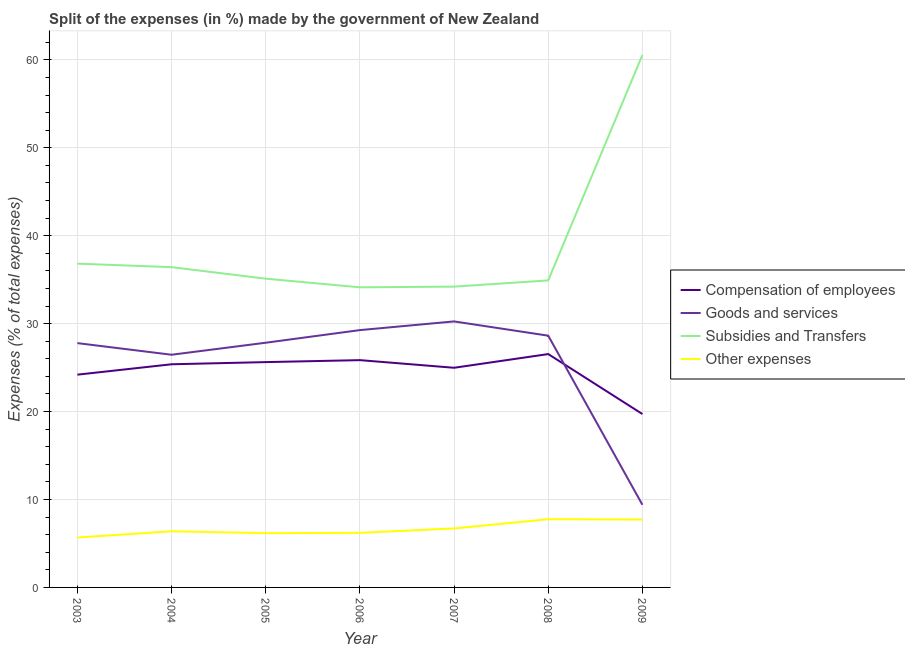How many different coloured lines are there?
Make the answer very short. 4. Does the line corresponding to percentage of amount spent on other expenses intersect with the line corresponding to percentage of amount spent on subsidies?
Ensure brevity in your answer.  No. Is the number of lines equal to the number of legend labels?
Ensure brevity in your answer.  Yes. What is the percentage of amount spent on other expenses in 2003?
Ensure brevity in your answer.  5.67. Across all years, what is the maximum percentage of amount spent on other expenses?
Provide a succinct answer. 7.75. Across all years, what is the minimum percentage of amount spent on other expenses?
Provide a short and direct response. 5.67. In which year was the percentage of amount spent on compensation of employees minimum?
Offer a terse response. 2009. What is the total percentage of amount spent on goods and services in the graph?
Give a very brief answer. 179.62. What is the difference between the percentage of amount spent on other expenses in 2007 and that in 2008?
Ensure brevity in your answer.  -1.05. What is the difference between the percentage of amount spent on other expenses in 2006 and the percentage of amount spent on compensation of employees in 2008?
Provide a succinct answer. -20.33. What is the average percentage of amount spent on goods and services per year?
Give a very brief answer. 25.66. In the year 2009, what is the difference between the percentage of amount spent on other expenses and percentage of amount spent on subsidies?
Keep it short and to the point. -52.83. In how many years, is the percentage of amount spent on goods and services greater than 16 %?
Provide a succinct answer. 6. What is the ratio of the percentage of amount spent on compensation of employees in 2003 to that in 2004?
Your answer should be compact. 0.95. Is the percentage of amount spent on compensation of employees in 2005 less than that in 2009?
Ensure brevity in your answer.  No. What is the difference between the highest and the second highest percentage of amount spent on goods and services?
Offer a terse response. 0.99. What is the difference between the highest and the lowest percentage of amount spent on subsidies?
Ensure brevity in your answer.  26.43. In how many years, is the percentage of amount spent on goods and services greater than the average percentage of amount spent on goods and services taken over all years?
Your answer should be very brief. 6. Is the sum of the percentage of amount spent on goods and services in 2003 and 2009 greater than the maximum percentage of amount spent on other expenses across all years?
Offer a terse response. Yes. Is it the case that in every year, the sum of the percentage of amount spent on subsidies and percentage of amount spent on goods and services is greater than the sum of percentage of amount spent on compensation of employees and percentage of amount spent on other expenses?
Your answer should be very brief. Yes. How many years are there in the graph?
Provide a succinct answer. 7. What is the difference between two consecutive major ticks on the Y-axis?
Offer a terse response. 10. Does the graph contain any zero values?
Ensure brevity in your answer.  No. Does the graph contain grids?
Offer a very short reply. Yes. Where does the legend appear in the graph?
Your response must be concise. Center right. What is the title of the graph?
Offer a terse response. Split of the expenses (in %) made by the government of New Zealand. Does "WFP" appear as one of the legend labels in the graph?
Your answer should be compact. No. What is the label or title of the X-axis?
Keep it short and to the point. Year. What is the label or title of the Y-axis?
Your answer should be compact. Expenses (% of total expenses). What is the Expenses (% of total expenses) of Compensation of employees in 2003?
Offer a very short reply. 24.2. What is the Expenses (% of total expenses) in Goods and services in 2003?
Your answer should be compact. 27.78. What is the Expenses (% of total expenses) of Subsidies and Transfers in 2003?
Your answer should be compact. 36.82. What is the Expenses (% of total expenses) in Other expenses in 2003?
Make the answer very short. 5.67. What is the Expenses (% of total expenses) of Compensation of employees in 2004?
Provide a succinct answer. 25.38. What is the Expenses (% of total expenses) of Goods and services in 2004?
Your answer should be compact. 26.46. What is the Expenses (% of total expenses) in Subsidies and Transfers in 2004?
Keep it short and to the point. 36.42. What is the Expenses (% of total expenses) in Other expenses in 2004?
Your response must be concise. 6.38. What is the Expenses (% of total expenses) of Compensation of employees in 2005?
Offer a terse response. 25.62. What is the Expenses (% of total expenses) of Goods and services in 2005?
Your response must be concise. 27.83. What is the Expenses (% of total expenses) in Subsidies and Transfers in 2005?
Your answer should be very brief. 35.11. What is the Expenses (% of total expenses) of Other expenses in 2005?
Provide a short and direct response. 6.17. What is the Expenses (% of total expenses) in Compensation of employees in 2006?
Your response must be concise. 25.85. What is the Expenses (% of total expenses) in Goods and services in 2006?
Make the answer very short. 29.26. What is the Expenses (% of total expenses) in Subsidies and Transfers in 2006?
Provide a short and direct response. 34.13. What is the Expenses (% of total expenses) in Other expenses in 2006?
Provide a short and direct response. 6.21. What is the Expenses (% of total expenses) in Compensation of employees in 2007?
Offer a very short reply. 24.98. What is the Expenses (% of total expenses) in Goods and services in 2007?
Your response must be concise. 30.25. What is the Expenses (% of total expenses) in Subsidies and Transfers in 2007?
Provide a short and direct response. 34.21. What is the Expenses (% of total expenses) in Other expenses in 2007?
Provide a succinct answer. 6.71. What is the Expenses (% of total expenses) of Compensation of employees in 2008?
Offer a terse response. 26.54. What is the Expenses (% of total expenses) of Goods and services in 2008?
Your response must be concise. 28.63. What is the Expenses (% of total expenses) in Subsidies and Transfers in 2008?
Offer a terse response. 34.91. What is the Expenses (% of total expenses) in Other expenses in 2008?
Keep it short and to the point. 7.75. What is the Expenses (% of total expenses) of Compensation of employees in 2009?
Give a very brief answer. 19.72. What is the Expenses (% of total expenses) of Goods and services in 2009?
Provide a succinct answer. 9.4. What is the Expenses (% of total expenses) of Subsidies and Transfers in 2009?
Your answer should be very brief. 60.55. What is the Expenses (% of total expenses) of Other expenses in 2009?
Keep it short and to the point. 7.73. Across all years, what is the maximum Expenses (% of total expenses) in Compensation of employees?
Keep it short and to the point. 26.54. Across all years, what is the maximum Expenses (% of total expenses) of Goods and services?
Your answer should be compact. 30.25. Across all years, what is the maximum Expenses (% of total expenses) in Subsidies and Transfers?
Make the answer very short. 60.55. Across all years, what is the maximum Expenses (% of total expenses) in Other expenses?
Offer a terse response. 7.75. Across all years, what is the minimum Expenses (% of total expenses) in Compensation of employees?
Offer a very short reply. 19.72. Across all years, what is the minimum Expenses (% of total expenses) in Goods and services?
Your answer should be very brief. 9.4. Across all years, what is the minimum Expenses (% of total expenses) in Subsidies and Transfers?
Your response must be concise. 34.13. Across all years, what is the minimum Expenses (% of total expenses) in Other expenses?
Offer a terse response. 5.67. What is the total Expenses (% of total expenses) of Compensation of employees in the graph?
Give a very brief answer. 172.28. What is the total Expenses (% of total expenses) of Goods and services in the graph?
Offer a very short reply. 179.62. What is the total Expenses (% of total expenses) of Subsidies and Transfers in the graph?
Give a very brief answer. 272.16. What is the total Expenses (% of total expenses) in Other expenses in the graph?
Provide a succinct answer. 46.62. What is the difference between the Expenses (% of total expenses) in Compensation of employees in 2003 and that in 2004?
Ensure brevity in your answer.  -1.18. What is the difference between the Expenses (% of total expenses) of Goods and services in 2003 and that in 2004?
Offer a terse response. 1.32. What is the difference between the Expenses (% of total expenses) of Subsidies and Transfers in 2003 and that in 2004?
Give a very brief answer. 0.4. What is the difference between the Expenses (% of total expenses) of Other expenses in 2003 and that in 2004?
Your answer should be very brief. -0.71. What is the difference between the Expenses (% of total expenses) of Compensation of employees in 2003 and that in 2005?
Make the answer very short. -1.43. What is the difference between the Expenses (% of total expenses) of Goods and services in 2003 and that in 2005?
Your answer should be very brief. -0.05. What is the difference between the Expenses (% of total expenses) of Subsidies and Transfers in 2003 and that in 2005?
Your response must be concise. 1.71. What is the difference between the Expenses (% of total expenses) of Other expenses in 2003 and that in 2005?
Offer a very short reply. -0.5. What is the difference between the Expenses (% of total expenses) of Compensation of employees in 2003 and that in 2006?
Your response must be concise. -1.65. What is the difference between the Expenses (% of total expenses) in Goods and services in 2003 and that in 2006?
Offer a very short reply. -1.48. What is the difference between the Expenses (% of total expenses) in Subsidies and Transfers in 2003 and that in 2006?
Ensure brevity in your answer.  2.69. What is the difference between the Expenses (% of total expenses) in Other expenses in 2003 and that in 2006?
Your response must be concise. -0.54. What is the difference between the Expenses (% of total expenses) in Compensation of employees in 2003 and that in 2007?
Ensure brevity in your answer.  -0.78. What is the difference between the Expenses (% of total expenses) of Goods and services in 2003 and that in 2007?
Make the answer very short. -2.47. What is the difference between the Expenses (% of total expenses) of Subsidies and Transfers in 2003 and that in 2007?
Ensure brevity in your answer.  2.62. What is the difference between the Expenses (% of total expenses) of Other expenses in 2003 and that in 2007?
Keep it short and to the point. -1.04. What is the difference between the Expenses (% of total expenses) of Compensation of employees in 2003 and that in 2008?
Your response must be concise. -2.34. What is the difference between the Expenses (% of total expenses) in Goods and services in 2003 and that in 2008?
Ensure brevity in your answer.  -0.85. What is the difference between the Expenses (% of total expenses) of Subsidies and Transfers in 2003 and that in 2008?
Offer a very short reply. 1.91. What is the difference between the Expenses (% of total expenses) in Other expenses in 2003 and that in 2008?
Ensure brevity in your answer.  -2.08. What is the difference between the Expenses (% of total expenses) in Compensation of employees in 2003 and that in 2009?
Keep it short and to the point. 4.48. What is the difference between the Expenses (% of total expenses) in Goods and services in 2003 and that in 2009?
Offer a terse response. 18.38. What is the difference between the Expenses (% of total expenses) in Subsidies and Transfers in 2003 and that in 2009?
Ensure brevity in your answer.  -23.73. What is the difference between the Expenses (% of total expenses) of Other expenses in 2003 and that in 2009?
Your response must be concise. -2.06. What is the difference between the Expenses (% of total expenses) of Compensation of employees in 2004 and that in 2005?
Make the answer very short. -0.25. What is the difference between the Expenses (% of total expenses) in Goods and services in 2004 and that in 2005?
Offer a terse response. -1.37. What is the difference between the Expenses (% of total expenses) in Subsidies and Transfers in 2004 and that in 2005?
Provide a short and direct response. 1.31. What is the difference between the Expenses (% of total expenses) of Other expenses in 2004 and that in 2005?
Give a very brief answer. 0.21. What is the difference between the Expenses (% of total expenses) in Compensation of employees in 2004 and that in 2006?
Your answer should be compact. -0.47. What is the difference between the Expenses (% of total expenses) in Goods and services in 2004 and that in 2006?
Your answer should be very brief. -2.8. What is the difference between the Expenses (% of total expenses) in Subsidies and Transfers in 2004 and that in 2006?
Give a very brief answer. 2.29. What is the difference between the Expenses (% of total expenses) in Other expenses in 2004 and that in 2006?
Offer a terse response. 0.17. What is the difference between the Expenses (% of total expenses) in Compensation of employees in 2004 and that in 2007?
Give a very brief answer. 0.4. What is the difference between the Expenses (% of total expenses) in Goods and services in 2004 and that in 2007?
Ensure brevity in your answer.  -3.79. What is the difference between the Expenses (% of total expenses) in Subsidies and Transfers in 2004 and that in 2007?
Offer a terse response. 2.22. What is the difference between the Expenses (% of total expenses) of Other expenses in 2004 and that in 2007?
Provide a succinct answer. -0.32. What is the difference between the Expenses (% of total expenses) in Compensation of employees in 2004 and that in 2008?
Offer a terse response. -1.16. What is the difference between the Expenses (% of total expenses) in Goods and services in 2004 and that in 2008?
Provide a succinct answer. -2.17. What is the difference between the Expenses (% of total expenses) of Subsidies and Transfers in 2004 and that in 2008?
Ensure brevity in your answer.  1.51. What is the difference between the Expenses (% of total expenses) of Other expenses in 2004 and that in 2008?
Give a very brief answer. -1.37. What is the difference between the Expenses (% of total expenses) of Compensation of employees in 2004 and that in 2009?
Offer a very short reply. 5.66. What is the difference between the Expenses (% of total expenses) of Goods and services in 2004 and that in 2009?
Provide a succinct answer. 17.06. What is the difference between the Expenses (% of total expenses) of Subsidies and Transfers in 2004 and that in 2009?
Offer a terse response. -24.13. What is the difference between the Expenses (% of total expenses) in Other expenses in 2004 and that in 2009?
Provide a succinct answer. -1.34. What is the difference between the Expenses (% of total expenses) in Compensation of employees in 2005 and that in 2006?
Give a very brief answer. -0.22. What is the difference between the Expenses (% of total expenses) in Goods and services in 2005 and that in 2006?
Your answer should be compact. -1.44. What is the difference between the Expenses (% of total expenses) in Subsidies and Transfers in 2005 and that in 2006?
Offer a terse response. 0.98. What is the difference between the Expenses (% of total expenses) in Other expenses in 2005 and that in 2006?
Ensure brevity in your answer.  -0.04. What is the difference between the Expenses (% of total expenses) of Compensation of employees in 2005 and that in 2007?
Offer a terse response. 0.64. What is the difference between the Expenses (% of total expenses) of Goods and services in 2005 and that in 2007?
Provide a short and direct response. -2.42. What is the difference between the Expenses (% of total expenses) in Subsidies and Transfers in 2005 and that in 2007?
Give a very brief answer. 0.91. What is the difference between the Expenses (% of total expenses) of Other expenses in 2005 and that in 2007?
Give a very brief answer. -0.54. What is the difference between the Expenses (% of total expenses) in Compensation of employees in 2005 and that in 2008?
Give a very brief answer. -0.91. What is the difference between the Expenses (% of total expenses) in Goods and services in 2005 and that in 2008?
Keep it short and to the point. -0.8. What is the difference between the Expenses (% of total expenses) of Subsidies and Transfers in 2005 and that in 2008?
Give a very brief answer. 0.2. What is the difference between the Expenses (% of total expenses) in Other expenses in 2005 and that in 2008?
Keep it short and to the point. -1.58. What is the difference between the Expenses (% of total expenses) of Compensation of employees in 2005 and that in 2009?
Make the answer very short. 5.9. What is the difference between the Expenses (% of total expenses) in Goods and services in 2005 and that in 2009?
Offer a terse response. 18.43. What is the difference between the Expenses (% of total expenses) in Subsidies and Transfers in 2005 and that in 2009?
Your answer should be very brief. -25.44. What is the difference between the Expenses (% of total expenses) of Other expenses in 2005 and that in 2009?
Your response must be concise. -1.56. What is the difference between the Expenses (% of total expenses) in Compensation of employees in 2006 and that in 2007?
Make the answer very short. 0.87. What is the difference between the Expenses (% of total expenses) in Goods and services in 2006 and that in 2007?
Your answer should be very brief. -0.99. What is the difference between the Expenses (% of total expenses) in Subsidies and Transfers in 2006 and that in 2007?
Offer a very short reply. -0.08. What is the difference between the Expenses (% of total expenses) of Other expenses in 2006 and that in 2007?
Your response must be concise. -0.5. What is the difference between the Expenses (% of total expenses) of Compensation of employees in 2006 and that in 2008?
Offer a terse response. -0.69. What is the difference between the Expenses (% of total expenses) in Goods and services in 2006 and that in 2008?
Give a very brief answer. 0.63. What is the difference between the Expenses (% of total expenses) of Subsidies and Transfers in 2006 and that in 2008?
Make the answer very short. -0.79. What is the difference between the Expenses (% of total expenses) in Other expenses in 2006 and that in 2008?
Offer a terse response. -1.55. What is the difference between the Expenses (% of total expenses) of Compensation of employees in 2006 and that in 2009?
Your response must be concise. 6.13. What is the difference between the Expenses (% of total expenses) of Goods and services in 2006 and that in 2009?
Your response must be concise. 19.87. What is the difference between the Expenses (% of total expenses) of Subsidies and Transfers in 2006 and that in 2009?
Your answer should be compact. -26.43. What is the difference between the Expenses (% of total expenses) in Other expenses in 2006 and that in 2009?
Offer a terse response. -1.52. What is the difference between the Expenses (% of total expenses) of Compensation of employees in 2007 and that in 2008?
Your response must be concise. -1.56. What is the difference between the Expenses (% of total expenses) in Goods and services in 2007 and that in 2008?
Your answer should be compact. 1.62. What is the difference between the Expenses (% of total expenses) in Subsidies and Transfers in 2007 and that in 2008?
Make the answer very short. -0.71. What is the difference between the Expenses (% of total expenses) of Other expenses in 2007 and that in 2008?
Your answer should be very brief. -1.05. What is the difference between the Expenses (% of total expenses) of Compensation of employees in 2007 and that in 2009?
Give a very brief answer. 5.26. What is the difference between the Expenses (% of total expenses) of Goods and services in 2007 and that in 2009?
Your answer should be compact. 20.85. What is the difference between the Expenses (% of total expenses) of Subsidies and Transfers in 2007 and that in 2009?
Give a very brief answer. -26.35. What is the difference between the Expenses (% of total expenses) in Other expenses in 2007 and that in 2009?
Offer a very short reply. -1.02. What is the difference between the Expenses (% of total expenses) in Compensation of employees in 2008 and that in 2009?
Your response must be concise. 6.82. What is the difference between the Expenses (% of total expenses) in Goods and services in 2008 and that in 2009?
Your response must be concise. 19.23. What is the difference between the Expenses (% of total expenses) in Subsidies and Transfers in 2008 and that in 2009?
Provide a succinct answer. -25.64. What is the difference between the Expenses (% of total expenses) in Other expenses in 2008 and that in 2009?
Provide a short and direct response. 0.03. What is the difference between the Expenses (% of total expenses) in Compensation of employees in 2003 and the Expenses (% of total expenses) in Goods and services in 2004?
Make the answer very short. -2.26. What is the difference between the Expenses (% of total expenses) in Compensation of employees in 2003 and the Expenses (% of total expenses) in Subsidies and Transfers in 2004?
Ensure brevity in your answer.  -12.23. What is the difference between the Expenses (% of total expenses) in Compensation of employees in 2003 and the Expenses (% of total expenses) in Other expenses in 2004?
Keep it short and to the point. 17.81. What is the difference between the Expenses (% of total expenses) of Goods and services in 2003 and the Expenses (% of total expenses) of Subsidies and Transfers in 2004?
Give a very brief answer. -8.64. What is the difference between the Expenses (% of total expenses) of Goods and services in 2003 and the Expenses (% of total expenses) of Other expenses in 2004?
Offer a very short reply. 21.4. What is the difference between the Expenses (% of total expenses) of Subsidies and Transfers in 2003 and the Expenses (% of total expenses) of Other expenses in 2004?
Make the answer very short. 30.44. What is the difference between the Expenses (% of total expenses) of Compensation of employees in 2003 and the Expenses (% of total expenses) of Goods and services in 2005?
Keep it short and to the point. -3.63. What is the difference between the Expenses (% of total expenses) in Compensation of employees in 2003 and the Expenses (% of total expenses) in Subsidies and Transfers in 2005?
Your answer should be compact. -10.92. What is the difference between the Expenses (% of total expenses) in Compensation of employees in 2003 and the Expenses (% of total expenses) in Other expenses in 2005?
Your response must be concise. 18.03. What is the difference between the Expenses (% of total expenses) of Goods and services in 2003 and the Expenses (% of total expenses) of Subsidies and Transfers in 2005?
Your answer should be compact. -7.33. What is the difference between the Expenses (% of total expenses) in Goods and services in 2003 and the Expenses (% of total expenses) in Other expenses in 2005?
Offer a terse response. 21.61. What is the difference between the Expenses (% of total expenses) in Subsidies and Transfers in 2003 and the Expenses (% of total expenses) in Other expenses in 2005?
Ensure brevity in your answer.  30.65. What is the difference between the Expenses (% of total expenses) of Compensation of employees in 2003 and the Expenses (% of total expenses) of Goods and services in 2006?
Offer a terse response. -5.07. What is the difference between the Expenses (% of total expenses) of Compensation of employees in 2003 and the Expenses (% of total expenses) of Subsidies and Transfers in 2006?
Provide a succinct answer. -9.93. What is the difference between the Expenses (% of total expenses) of Compensation of employees in 2003 and the Expenses (% of total expenses) of Other expenses in 2006?
Make the answer very short. 17.99. What is the difference between the Expenses (% of total expenses) in Goods and services in 2003 and the Expenses (% of total expenses) in Subsidies and Transfers in 2006?
Offer a very short reply. -6.35. What is the difference between the Expenses (% of total expenses) in Goods and services in 2003 and the Expenses (% of total expenses) in Other expenses in 2006?
Ensure brevity in your answer.  21.57. What is the difference between the Expenses (% of total expenses) in Subsidies and Transfers in 2003 and the Expenses (% of total expenses) in Other expenses in 2006?
Your answer should be very brief. 30.61. What is the difference between the Expenses (% of total expenses) in Compensation of employees in 2003 and the Expenses (% of total expenses) in Goods and services in 2007?
Provide a short and direct response. -6.05. What is the difference between the Expenses (% of total expenses) of Compensation of employees in 2003 and the Expenses (% of total expenses) of Subsidies and Transfers in 2007?
Your answer should be compact. -10.01. What is the difference between the Expenses (% of total expenses) of Compensation of employees in 2003 and the Expenses (% of total expenses) of Other expenses in 2007?
Offer a very short reply. 17.49. What is the difference between the Expenses (% of total expenses) of Goods and services in 2003 and the Expenses (% of total expenses) of Subsidies and Transfers in 2007?
Provide a succinct answer. -6.42. What is the difference between the Expenses (% of total expenses) of Goods and services in 2003 and the Expenses (% of total expenses) of Other expenses in 2007?
Give a very brief answer. 21.08. What is the difference between the Expenses (% of total expenses) in Subsidies and Transfers in 2003 and the Expenses (% of total expenses) in Other expenses in 2007?
Give a very brief answer. 30.11. What is the difference between the Expenses (% of total expenses) of Compensation of employees in 2003 and the Expenses (% of total expenses) of Goods and services in 2008?
Provide a short and direct response. -4.43. What is the difference between the Expenses (% of total expenses) in Compensation of employees in 2003 and the Expenses (% of total expenses) in Subsidies and Transfers in 2008?
Provide a short and direct response. -10.72. What is the difference between the Expenses (% of total expenses) of Compensation of employees in 2003 and the Expenses (% of total expenses) of Other expenses in 2008?
Make the answer very short. 16.44. What is the difference between the Expenses (% of total expenses) in Goods and services in 2003 and the Expenses (% of total expenses) in Subsidies and Transfers in 2008?
Provide a short and direct response. -7.13. What is the difference between the Expenses (% of total expenses) in Goods and services in 2003 and the Expenses (% of total expenses) in Other expenses in 2008?
Your answer should be compact. 20.03. What is the difference between the Expenses (% of total expenses) in Subsidies and Transfers in 2003 and the Expenses (% of total expenses) in Other expenses in 2008?
Provide a succinct answer. 29.07. What is the difference between the Expenses (% of total expenses) in Compensation of employees in 2003 and the Expenses (% of total expenses) in Goods and services in 2009?
Provide a short and direct response. 14.8. What is the difference between the Expenses (% of total expenses) of Compensation of employees in 2003 and the Expenses (% of total expenses) of Subsidies and Transfers in 2009?
Offer a very short reply. -36.36. What is the difference between the Expenses (% of total expenses) of Compensation of employees in 2003 and the Expenses (% of total expenses) of Other expenses in 2009?
Your response must be concise. 16.47. What is the difference between the Expenses (% of total expenses) in Goods and services in 2003 and the Expenses (% of total expenses) in Subsidies and Transfers in 2009?
Your answer should be very brief. -32.77. What is the difference between the Expenses (% of total expenses) of Goods and services in 2003 and the Expenses (% of total expenses) of Other expenses in 2009?
Provide a short and direct response. 20.05. What is the difference between the Expenses (% of total expenses) of Subsidies and Transfers in 2003 and the Expenses (% of total expenses) of Other expenses in 2009?
Provide a short and direct response. 29.09. What is the difference between the Expenses (% of total expenses) of Compensation of employees in 2004 and the Expenses (% of total expenses) of Goods and services in 2005?
Your answer should be very brief. -2.45. What is the difference between the Expenses (% of total expenses) of Compensation of employees in 2004 and the Expenses (% of total expenses) of Subsidies and Transfers in 2005?
Your answer should be very brief. -9.73. What is the difference between the Expenses (% of total expenses) in Compensation of employees in 2004 and the Expenses (% of total expenses) in Other expenses in 2005?
Your response must be concise. 19.21. What is the difference between the Expenses (% of total expenses) of Goods and services in 2004 and the Expenses (% of total expenses) of Subsidies and Transfers in 2005?
Provide a succinct answer. -8.65. What is the difference between the Expenses (% of total expenses) in Goods and services in 2004 and the Expenses (% of total expenses) in Other expenses in 2005?
Offer a very short reply. 20.29. What is the difference between the Expenses (% of total expenses) in Subsidies and Transfers in 2004 and the Expenses (% of total expenses) in Other expenses in 2005?
Your response must be concise. 30.25. What is the difference between the Expenses (% of total expenses) in Compensation of employees in 2004 and the Expenses (% of total expenses) in Goods and services in 2006?
Provide a short and direct response. -3.89. What is the difference between the Expenses (% of total expenses) in Compensation of employees in 2004 and the Expenses (% of total expenses) in Subsidies and Transfers in 2006?
Your answer should be compact. -8.75. What is the difference between the Expenses (% of total expenses) in Compensation of employees in 2004 and the Expenses (% of total expenses) in Other expenses in 2006?
Provide a succinct answer. 19.17. What is the difference between the Expenses (% of total expenses) of Goods and services in 2004 and the Expenses (% of total expenses) of Subsidies and Transfers in 2006?
Ensure brevity in your answer.  -7.67. What is the difference between the Expenses (% of total expenses) in Goods and services in 2004 and the Expenses (% of total expenses) in Other expenses in 2006?
Offer a very short reply. 20.25. What is the difference between the Expenses (% of total expenses) in Subsidies and Transfers in 2004 and the Expenses (% of total expenses) in Other expenses in 2006?
Ensure brevity in your answer.  30.21. What is the difference between the Expenses (% of total expenses) in Compensation of employees in 2004 and the Expenses (% of total expenses) in Goods and services in 2007?
Your answer should be compact. -4.87. What is the difference between the Expenses (% of total expenses) of Compensation of employees in 2004 and the Expenses (% of total expenses) of Subsidies and Transfers in 2007?
Keep it short and to the point. -8.83. What is the difference between the Expenses (% of total expenses) of Compensation of employees in 2004 and the Expenses (% of total expenses) of Other expenses in 2007?
Give a very brief answer. 18.67. What is the difference between the Expenses (% of total expenses) in Goods and services in 2004 and the Expenses (% of total expenses) in Subsidies and Transfers in 2007?
Your answer should be very brief. -7.75. What is the difference between the Expenses (% of total expenses) in Goods and services in 2004 and the Expenses (% of total expenses) in Other expenses in 2007?
Your answer should be compact. 19.75. What is the difference between the Expenses (% of total expenses) in Subsidies and Transfers in 2004 and the Expenses (% of total expenses) in Other expenses in 2007?
Make the answer very short. 29.72. What is the difference between the Expenses (% of total expenses) in Compensation of employees in 2004 and the Expenses (% of total expenses) in Goods and services in 2008?
Ensure brevity in your answer.  -3.25. What is the difference between the Expenses (% of total expenses) of Compensation of employees in 2004 and the Expenses (% of total expenses) of Subsidies and Transfers in 2008?
Provide a short and direct response. -9.54. What is the difference between the Expenses (% of total expenses) of Compensation of employees in 2004 and the Expenses (% of total expenses) of Other expenses in 2008?
Provide a short and direct response. 17.62. What is the difference between the Expenses (% of total expenses) in Goods and services in 2004 and the Expenses (% of total expenses) in Subsidies and Transfers in 2008?
Your response must be concise. -8.45. What is the difference between the Expenses (% of total expenses) of Goods and services in 2004 and the Expenses (% of total expenses) of Other expenses in 2008?
Your answer should be very brief. 18.71. What is the difference between the Expenses (% of total expenses) of Subsidies and Transfers in 2004 and the Expenses (% of total expenses) of Other expenses in 2008?
Your answer should be very brief. 28.67. What is the difference between the Expenses (% of total expenses) of Compensation of employees in 2004 and the Expenses (% of total expenses) of Goods and services in 2009?
Your answer should be compact. 15.98. What is the difference between the Expenses (% of total expenses) of Compensation of employees in 2004 and the Expenses (% of total expenses) of Subsidies and Transfers in 2009?
Ensure brevity in your answer.  -35.18. What is the difference between the Expenses (% of total expenses) of Compensation of employees in 2004 and the Expenses (% of total expenses) of Other expenses in 2009?
Provide a short and direct response. 17.65. What is the difference between the Expenses (% of total expenses) of Goods and services in 2004 and the Expenses (% of total expenses) of Subsidies and Transfers in 2009?
Offer a terse response. -34.09. What is the difference between the Expenses (% of total expenses) in Goods and services in 2004 and the Expenses (% of total expenses) in Other expenses in 2009?
Give a very brief answer. 18.73. What is the difference between the Expenses (% of total expenses) in Subsidies and Transfers in 2004 and the Expenses (% of total expenses) in Other expenses in 2009?
Keep it short and to the point. 28.69. What is the difference between the Expenses (% of total expenses) of Compensation of employees in 2005 and the Expenses (% of total expenses) of Goods and services in 2006?
Keep it short and to the point. -3.64. What is the difference between the Expenses (% of total expenses) in Compensation of employees in 2005 and the Expenses (% of total expenses) in Subsidies and Transfers in 2006?
Keep it short and to the point. -8.51. What is the difference between the Expenses (% of total expenses) of Compensation of employees in 2005 and the Expenses (% of total expenses) of Other expenses in 2006?
Make the answer very short. 19.41. What is the difference between the Expenses (% of total expenses) in Goods and services in 2005 and the Expenses (% of total expenses) in Subsidies and Transfers in 2006?
Your response must be concise. -6.3. What is the difference between the Expenses (% of total expenses) in Goods and services in 2005 and the Expenses (% of total expenses) in Other expenses in 2006?
Give a very brief answer. 21.62. What is the difference between the Expenses (% of total expenses) of Subsidies and Transfers in 2005 and the Expenses (% of total expenses) of Other expenses in 2006?
Your answer should be compact. 28.9. What is the difference between the Expenses (% of total expenses) of Compensation of employees in 2005 and the Expenses (% of total expenses) of Goods and services in 2007?
Give a very brief answer. -4.63. What is the difference between the Expenses (% of total expenses) in Compensation of employees in 2005 and the Expenses (% of total expenses) in Subsidies and Transfers in 2007?
Your answer should be very brief. -8.58. What is the difference between the Expenses (% of total expenses) in Compensation of employees in 2005 and the Expenses (% of total expenses) in Other expenses in 2007?
Keep it short and to the point. 18.92. What is the difference between the Expenses (% of total expenses) of Goods and services in 2005 and the Expenses (% of total expenses) of Subsidies and Transfers in 2007?
Provide a succinct answer. -6.38. What is the difference between the Expenses (% of total expenses) of Goods and services in 2005 and the Expenses (% of total expenses) of Other expenses in 2007?
Provide a short and direct response. 21.12. What is the difference between the Expenses (% of total expenses) in Subsidies and Transfers in 2005 and the Expenses (% of total expenses) in Other expenses in 2007?
Your response must be concise. 28.41. What is the difference between the Expenses (% of total expenses) of Compensation of employees in 2005 and the Expenses (% of total expenses) of Goods and services in 2008?
Provide a succinct answer. -3.01. What is the difference between the Expenses (% of total expenses) in Compensation of employees in 2005 and the Expenses (% of total expenses) in Subsidies and Transfers in 2008?
Provide a short and direct response. -9.29. What is the difference between the Expenses (% of total expenses) of Compensation of employees in 2005 and the Expenses (% of total expenses) of Other expenses in 2008?
Provide a succinct answer. 17.87. What is the difference between the Expenses (% of total expenses) in Goods and services in 2005 and the Expenses (% of total expenses) in Subsidies and Transfers in 2008?
Your response must be concise. -7.09. What is the difference between the Expenses (% of total expenses) in Goods and services in 2005 and the Expenses (% of total expenses) in Other expenses in 2008?
Offer a terse response. 20.07. What is the difference between the Expenses (% of total expenses) of Subsidies and Transfers in 2005 and the Expenses (% of total expenses) of Other expenses in 2008?
Make the answer very short. 27.36. What is the difference between the Expenses (% of total expenses) of Compensation of employees in 2005 and the Expenses (% of total expenses) of Goods and services in 2009?
Your response must be concise. 16.23. What is the difference between the Expenses (% of total expenses) in Compensation of employees in 2005 and the Expenses (% of total expenses) in Subsidies and Transfers in 2009?
Offer a terse response. -34.93. What is the difference between the Expenses (% of total expenses) in Compensation of employees in 2005 and the Expenses (% of total expenses) in Other expenses in 2009?
Your answer should be compact. 17.9. What is the difference between the Expenses (% of total expenses) in Goods and services in 2005 and the Expenses (% of total expenses) in Subsidies and Transfers in 2009?
Provide a succinct answer. -32.73. What is the difference between the Expenses (% of total expenses) of Goods and services in 2005 and the Expenses (% of total expenses) of Other expenses in 2009?
Offer a very short reply. 20.1. What is the difference between the Expenses (% of total expenses) of Subsidies and Transfers in 2005 and the Expenses (% of total expenses) of Other expenses in 2009?
Keep it short and to the point. 27.38. What is the difference between the Expenses (% of total expenses) in Compensation of employees in 2006 and the Expenses (% of total expenses) in Goods and services in 2007?
Offer a very short reply. -4.4. What is the difference between the Expenses (% of total expenses) of Compensation of employees in 2006 and the Expenses (% of total expenses) of Subsidies and Transfers in 2007?
Offer a terse response. -8.36. What is the difference between the Expenses (% of total expenses) in Compensation of employees in 2006 and the Expenses (% of total expenses) in Other expenses in 2007?
Offer a very short reply. 19.14. What is the difference between the Expenses (% of total expenses) in Goods and services in 2006 and the Expenses (% of total expenses) in Subsidies and Transfers in 2007?
Make the answer very short. -4.94. What is the difference between the Expenses (% of total expenses) of Goods and services in 2006 and the Expenses (% of total expenses) of Other expenses in 2007?
Keep it short and to the point. 22.56. What is the difference between the Expenses (% of total expenses) in Subsidies and Transfers in 2006 and the Expenses (% of total expenses) in Other expenses in 2007?
Offer a terse response. 27.42. What is the difference between the Expenses (% of total expenses) of Compensation of employees in 2006 and the Expenses (% of total expenses) of Goods and services in 2008?
Your answer should be very brief. -2.78. What is the difference between the Expenses (% of total expenses) in Compensation of employees in 2006 and the Expenses (% of total expenses) in Subsidies and Transfers in 2008?
Give a very brief answer. -9.07. What is the difference between the Expenses (% of total expenses) in Compensation of employees in 2006 and the Expenses (% of total expenses) in Other expenses in 2008?
Give a very brief answer. 18.09. What is the difference between the Expenses (% of total expenses) in Goods and services in 2006 and the Expenses (% of total expenses) in Subsidies and Transfers in 2008?
Your answer should be compact. -5.65. What is the difference between the Expenses (% of total expenses) in Goods and services in 2006 and the Expenses (% of total expenses) in Other expenses in 2008?
Provide a succinct answer. 21.51. What is the difference between the Expenses (% of total expenses) in Subsidies and Transfers in 2006 and the Expenses (% of total expenses) in Other expenses in 2008?
Offer a terse response. 26.37. What is the difference between the Expenses (% of total expenses) in Compensation of employees in 2006 and the Expenses (% of total expenses) in Goods and services in 2009?
Make the answer very short. 16.45. What is the difference between the Expenses (% of total expenses) in Compensation of employees in 2006 and the Expenses (% of total expenses) in Subsidies and Transfers in 2009?
Give a very brief answer. -34.71. What is the difference between the Expenses (% of total expenses) of Compensation of employees in 2006 and the Expenses (% of total expenses) of Other expenses in 2009?
Provide a succinct answer. 18.12. What is the difference between the Expenses (% of total expenses) in Goods and services in 2006 and the Expenses (% of total expenses) in Subsidies and Transfers in 2009?
Offer a terse response. -31.29. What is the difference between the Expenses (% of total expenses) of Goods and services in 2006 and the Expenses (% of total expenses) of Other expenses in 2009?
Keep it short and to the point. 21.54. What is the difference between the Expenses (% of total expenses) in Subsidies and Transfers in 2006 and the Expenses (% of total expenses) in Other expenses in 2009?
Your answer should be compact. 26.4. What is the difference between the Expenses (% of total expenses) of Compensation of employees in 2007 and the Expenses (% of total expenses) of Goods and services in 2008?
Ensure brevity in your answer.  -3.65. What is the difference between the Expenses (% of total expenses) of Compensation of employees in 2007 and the Expenses (% of total expenses) of Subsidies and Transfers in 2008?
Ensure brevity in your answer.  -9.94. What is the difference between the Expenses (% of total expenses) of Compensation of employees in 2007 and the Expenses (% of total expenses) of Other expenses in 2008?
Your response must be concise. 17.23. What is the difference between the Expenses (% of total expenses) of Goods and services in 2007 and the Expenses (% of total expenses) of Subsidies and Transfers in 2008?
Your response must be concise. -4.66. What is the difference between the Expenses (% of total expenses) of Goods and services in 2007 and the Expenses (% of total expenses) of Other expenses in 2008?
Your answer should be very brief. 22.5. What is the difference between the Expenses (% of total expenses) in Subsidies and Transfers in 2007 and the Expenses (% of total expenses) in Other expenses in 2008?
Offer a very short reply. 26.45. What is the difference between the Expenses (% of total expenses) in Compensation of employees in 2007 and the Expenses (% of total expenses) in Goods and services in 2009?
Offer a terse response. 15.58. What is the difference between the Expenses (% of total expenses) of Compensation of employees in 2007 and the Expenses (% of total expenses) of Subsidies and Transfers in 2009?
Keep it short and to the point. -35.58. What is the difference between the Expenses (% of total expenses) in Compensation of employees in 2007 and the Expenses (% of total expenses) in Other expenses in 2009?
Make the answer very short. 17.25. What is the difference between the Expenses (% of total expenses) of Goods and services in 2007 and the Expenses (% of total expenses) of Subsidies and Transfers in 2009?
Offer a very short reply. -30.3. What is the difference between the Expenses (% of total expenses) of Goods and services in 2007 and the Expenses (% of total expenses) of Other expenses in 2009?
Provide a succinct answer. 22.52. What is the difference between the Expenses (% of total expenses) of Subsidies and Transfers in 2007 and the Expenses (% of total expenses) of Other expenses in 2009?
Ensure brevity in your answer.  26.48. What is the difference between the Expenses (% of total expenses) of Compensation of employees in 2008 and the Expenses (% of total expenses) of Goods and services in 2009?
Keep it short and to the point. 17.14. What is the difference between the Expenses (% of total expenses) of Compensation of employees in 2008 and the Expenses (% of total expenses) of Subsidies and Transfers in 2009?
Provide a short and direct response. -34.02. What is the difference between the Expenses (% of total expenses) in Compensation of employees in 2008 and the Expenses (% of total expenses) in Other expenses in 2009?
Provide a succinct answer. 18.81. What is the difference between the Expenses (% of total expenses) in Goods and services in 2008 and the Expenses (% of total expenses) in Subsidies and Transfers in 2009?
Your answer should be very brief. -31.93. What is the difference between the Expenses (% of total expenses) in Goods and services in 2008 and the Expenses (% of total expenses) in Other expenses in 2009?
Your response must be concise. 20.9. What is the difference between the Expenses (% of total expenses) in Subsidies and Transfers in 2008 and the Expenses (% of total expenses) in Other expenses in 2009?
Keep it short and to the point. 27.19. What is the average Expenses (% of total expenses) of Compensation of employees per year?
Provide a succinct answer. 24.61. What is the average Expenses (% of total expenses) of Goods and services per year?
Offer a terse response. 25.66. What is the average Expenses (% of total expenses) in Subsidies and Transfers per year?
Give a very brief answer. 38.88. What is the average Expenses (% of total expenses) in Other expenses per year?
Keep it short and to the point. 6.66. In the year 2003, what is the difference between the Expenses (% of total expenses) in Compensation of employees and Expenses (% of total expenses) in Goods and services?
Keep it short and to the point. -3.59. In the year 2003, what is the difference between the Expenses (% of total expenses) in Compensation of employees and Expenses (% of total expenses) in Subsidies and Transfers?
Your response must be concise. -12.62. In the year 2003, what is the difference between the Expenses (% of total expenses) in Compensation of employees and Expenses (% of total expenses) in Other expenses?
Ensure brevity in your answer.  18.53. In the year 2003, what is the difference between the Expenses (% of total expenses) in Goods and services and Expenses (% of total expenses) in Subsidies and Transfers?
Your response must be concise. -9.04. In the year 2003, what is the difference between the Expenses (% of total expenses) of Goods and services and Expenses (% of total expenses) of Other expenses?
Your answer should be very brief. 22.11. In the year 2003, what is the difference between the Expenses (% of total expenses) in Subsidies and Transfers and Expenses (% of total expenses) in Other expenses?
Provide a succinct answer. 31.15. In the year 2004, what is the difference between the Expenses (% of total expenses) in Compensation of employees and Expenses (% of total expenses) in Goods and services?
Give a very brief answer. -1.08. In the year 2004, what is the difference between the Expenses (% of total expenses) in Compensation of employees and Expenses (% of total expenses) in Subsidies and Transfers?
Offer a very short reply. -11.04. In the year 2004, what is the difference between the Expenses (% of total expenses) of Compensation of employees and Expenses (% of total expenses) of Other expenses?
Your answer should be compact. 18.99. In the year 2004, what is the difference between the Expenses (% of total expenses) of Goods and services and Expenses (% of total expenses) of Subsidies and Transfers?
Your answer should be very brief. -9.96. In the year 2004, what is the difference between the Expenses (% of total expenses) in Goods and services and Expenses (% of total expenses) in Other expenses?
Offer a very short reply. 20.08. In the year 2004, what is the difference between the Expenses (% of total expenses) in Subsidies and Transfers and Expenses (% of total expenses) in Other expenses?
Offer a terse response. 30.04. In the year 2005, what is the difference between the Expenses (% of total expenses) of Compensation of employees and Expenses (% of total expenses) of Goods and services?
Your response must be concise. -2.2. In the year 2005, what is the difference between the Expenses (% of total expenses) in Compensation of employees and Expenses (% of total expenses) in Subsidies and Transfers?
Your answer should be very brief. -9.49. In the year 2005, what is the difference between the Expenses (% of total expenses) in Compensation of employees and Expenses (% of total expenses) in Other expenses?
Your answer should be compact. 19.45. In the year 2005, what is the difference between the Expenses (% of total expenses) in Goods and services and Expenses (% of total expenses) in Subsidies and Transfers?
Keep it short and to the point. -7.28. In the year 2005, what is the difference between the Expenses (% of total expenses) of Goods and services and Expenses (% of total expenses) of Other expenses?
Make the answer very short. 21.66. In the year 2005, what is the difference between the Expenses (% of total expenses) of Subsidies and Transfers and Expenses (% of total expenses) of Other expenses?
Make the answer very short. 28.94. In the year 2006, what is the difference between the Expenses (% of total expenses) of Compensation of employees and Expenses (% of total expenses) of Goods and services?
Your answer should be very brief. -3.42. In the year 2006, what is the difference between the Expenses (% of total expenses) in Compensation of employees and Expenses (% of total expenses) in Subsidies and Transfers?
Your answer should be compact. -8.28. In the year 2006, what is the difference between the Expenses (% of total expenses) in Compensation of employees and Expenses (% of total expenses) in Other expenses?
Give a very brief answer. 19.64. In the year 2006, what is the difference between the Expenses (% of total expenses) in Goods and services and Expenses (% of total expenses) in Subsidies and Transfers?
Provide a succinct answer. -4.86. In the year 2006, what is the difference between the Expenses (% of total expenses) in Goods and services and Expenses (% of total expenses) in Other expenses?
Offer a very short reply. 23.05. In the year 2006, what is the difference between the Expenses (% of total expenses) in Subsidies and Transfers and Expenses (% of total expenses) in Other expenses?
Your response must be concise. 27.92. In the year 2007, what is the difference between the Expenses (% of total expenses) in Compensation of employees and Expenses (% of total expenses) in Goods and services?
Ensure brevity in your answer.  -5.27. In the year 2007, what is the difference between the Expenses (% of total expenses) of Compensation of employees and Expenses (% of total expenses) of Subsidies and Transfers?
Give a very brief answer. -9.23. In the year 2007, what is the difference between the Expenses (% of total expenses) in Compensation of employees and Expenses (% of total expenses) in Other expenses?
Your answer should be compact. 18.27. In the year 2007, what is the difference between the Expenses (% of total expenses) of Goods and services and Expenses (% of total expenses) of Subsidies and Transfers?
Your answer should be compact. -3.96. In the year 2007, what is the difference between the Expenses (% of total expenses) in Goods and services and Expenses (% of total expenses) in Other expenses?
Make the answer very short. 23.54. In the year 2007, what is the difference between the Expenses (% of total expenses) in Subsidies and Transfers and Expenses (% of total expenses) in Other expenses?
Offer a terse response. 27.5. In the year 2008, what is the difference between the Expenses (% of total expenses) of Compensation of employees and Expenses (% of total expenses) of Goods and services?
Make the answer very short. -2.09. In the year 2008, what is the difference between the Expenses (% of total expenses) of Compensation of employees and Expenses (% of total expenses) of Subsidies and Transfers?
Offer a very short reply. -8.38. In the year 2008, what is the difference between the Expenses (% of total expenses) of Compensation of employees and Expenses (% of total expenses) of Other expenses?
Make the answer very short. 18.78. In the year 2008, what is the difference between the Expenses (% of total expenses) in Goods and services and Expenses (% of total expenses) in Subsidies and Transfers?
Provide a succinct answer. -6.29. In the year 2008, what is the difference between the Expenses (% of total expenses) of Goods and services and Expenses (% of total expenses) of Other expenses?
Provide a succinct answer. 20.88. In the year 2008, what is the difference between the Expenses (% of total expenses) in Subsidies and Transfers and Expenses (% of total expenses) in Other expenses?
Your response must be concise. 27.16. In the year 2009, what is the difference between the Expenses (% of total expenses) of Compensation of employees and Expenses (% of total expenses) of Goods and services?
Your answer should be compact. 10.32. In the year 2009, what is the difference between the Expenses (% of total expenses) in Compensation of employees and Expenses (% of total expenses) in Subsidies and Transfers?
Give a very brief answer. -40.84. In the year 2009, what is the difference between the Expenses (% of total expenses) of Compensation of employees and Expenses (% of total expenses) of Other expenses?
Ensure brevity in your answer.  11.99. In the year 2009, what is the difference between the Expenses (% of total expenses) in Goods and services and Expenses (% of total expenses) in Subsidies and Transfers?
Keep it short and to the point. -51.16. In the year 2009, what is the difference between the Expenses (% of total expenses) of Goods and services and Expenses (% of total expenses) of Other expenses?
Your answer should be very brief. 1.67. In the year 2009, what is the difference between the Expenses (% of total expenses) in Subsidies and Transfers and Expenses (% of total expenses) in Other expenses?
Keep it short and to the point. 52.83. What is the ratio of the Expenses (% of total expenses) in Compensation of employees in 2003 to that in 2004?
Keep it short and to the point. 0.95. What is the ratio of the Expenses (% of total expenses) in Goods and services in 2003 to that in 2004?
Provide a short and direct response. 1.05. What is the ratio of the Expenses (% of total expenses) in Subsidies and Transfers in 2003 to that in 2004?
Your response must be concise. 1.01. What is the ratio of the Expenses (% of total expenses) in Other expenses in 2003 to that in 2004?
Ensure brevity in your answer.  0.89. What is the ratio of the Expenses (% of total expenses) in Compensation of employees in 2003 to that in 2005?
Ensure brevity in your answer.  0.94. What is the ratio of the Expenses (% of total expenses) in Goods and services in 2003 to that in 2005?
Give a very brief answer. 1. What is the ratio of the Expenses (% of total expenses) of Subsidies and Transfers in 2003 to that in 2005?
Offer a terse response. 1.05. What is the ratio of the Expenses (% of total expenses) in Other expenses in 2003 to that in 2005?
Your response must be concise. 0.92. What is the ratio of the Expenses (% of total expenses) of Compensation of employees in 2003 to that in 2006?
Provide a short and direct response. 0.94. What is the ratio of the Expenses (% of total expenses) of Goods and services in 2003 to that in 2006?
Give a very brief answer. 0.95. What is the ratio of the Expenses (% of total expenses) of Subsidies and Transfers in 2003 to that in 2006?
Give a very brief answer. 1.08. What is the ratio of the Expenses (% of total expenses) of Other expenses in 2003 to that in 2006?
Your response must be concise. 0.91. What is the ratio of the Expenses (% of total expenses) of Compensation of employees in 2003 to that in 2007?
Provide a short and direct response. 0.97. What is the ratio of the Expenses (% of total expenses) in Goods and services in 2003 to that in 2007?
Give a very brief answer. 0.92. What is the ratio of the Expenses (% of total expenses) in Subsidies and Transfers in 2003 to that in 2007?
Keep it short and to the point. 1.08. What is the ratio of the Expenses (% of total expenses) in Other expenses in 2003 to that in 2007?
Give a very brief answer. 0.85. What is the ratio of the Expenses (% of total expenses) in Compensation of employees in 2003 to that in 2008?
Offer a very short reply. 0.91. What is the ratio of the Expenses (% of total expenses) of Goods and services in 2003 to that in 2008?
Keep it short and to the point. 0.97. What is the ratio of the Expenses (% of total expenses) in Subsidies and Transfers in 2003 to that in 2008?
Your answer should be very brief. 1.05. What is the ratio of the Expenses (% of total expenses) in Other expenses in 2003 to that in 2008?
Provide a succinct answer. 0.73. What is the ratio of the Expenses (% of total expenses) in Compensation of employees in 2003 to that in 2009?
Offer a terse response. 1.23. What is the ratio of the Expenses (% of total expenses) in Goods and services in 2003 to that in 2009?
Offer a very short reply. 2.96. What is the ratio of the Expenses (% of total expenses) of Subsidies and Transfers in 2003 to that in 2009?
Give a very brief answer. 0.61. What is the ratio of the Expenses (% of total expenses) of Other expenses in 2003 to that in 2009?
Offer a terse response. 0.73. What is the ratio of the Expenses (% of total expenses) in Goods and services in 2004 to that in 2005?
Make the answer very short. 0.95. What is the ratio of the Expenses (% of total expenses) of Subsidies and Transfers in 2004 to that in 2005?
Offer a terse response. 1.04. What is the ratio of the Expenses (% of total expenses) of Other expenses in 2004 to that in 2005?
Your answer should be compact. 1.03. What is the ratio of the Expenses (% of total expenses) in Compensation of employees in 2004 to that in 2006?
Ensure brevity in your answer.  0.98. What is the ratio of the Expenses (% of total expenses) in Goods and services in 2004 to that in 2006?
Make the answer very short. 0.9. What is the ratio of the Expenses (% of total expenses) of Subsidies and Transfers in 2004 to that in 2006?
Ensure brevity in your answer.  1.07. What is the ratio of the Expenses (% of total expenses) in Other expenses in 2004 to that in 2006?
Provide a succinct answer. 1.03. What is the ratio of the Expenses (% of total expenses) of Goods and services in 2004 to that in 2007?
Your answer should be very brief. 0.87. What is the ratio of the Expenses (% of total expenses) in Subsidies and Transfers in 2004 to that in 2007?
Provide a short and direct response. 1.06. What is the ratio of the Expenses (% of total expenses) of Other expenses in 2004 to that in 2007?
Your answer should be compact. 0.95. What is the ratio of the Expenses (% of total expenses) of Compensation of employees in 2004 to that in 2008?
Your answer should be compact. 0.96. What is the ratio of the Expenses (% of total expenses) of Goods and services in 2004 to that in 2008?
Make the answer very short. 0.92. What is the ratio of the Expenses (% of total expenses) of Subsidies and Transfers in 2004 to that in 2008?
Your response must be concise. 1.04. What is the ratio of the Expenses (% of total expenses) in Other expenses in 2004 to that in 2008?
Offer a very short reply. 0.82. What is the ratio of the Expenses (% of total expenses) of Compensation of employees in 2004 to that in 2009?
Offer a terse response. 1.29. What is the ratio of the Expenses (% of total expenses) of Goods and services in 2004 to that in 2009?
Provide a succinct answer. 2.82. What is the ratio of the Expenses (% of total expenses) of Subsidies and Transfers in 2004 to that in 2009?
Offer a very short reply. 0.6. What is the ratio of the Expenses (% of total expenses) of Other expenses in 2004 to that in 2009?
Your answer should be very brief. 0.83. What is the ratio of the Expenses (% of total expenses) in Goods and services in 2005 to that in 2006?
Offer a very short reply. 0.95. What is the ratio of the Expenses (% of total expenses) of Subsidies and Transfers in 2005 to that in 2006?
Ensure brevity in your answer.  1.03. What is the ratio of the Expenses (% of total expenses) of Compensation of employees in 2005 to that in 2007?
Make the answer very short. 1.03. What is the ratio of the Expenses (% of total expenses) in Goods and services in 2005 to that in 2007?
Provide a succinct answer. 0.92. What is the ratio of the Expenses (% of total expenses) in Subsidies and Transfers in 2005 to that in 2007?
Your answer should be compact. 1.03. What is the ratio of the Expenses (% of total expenses) of Compensation of employees in 2005 to that in 2008?
Give a very brief answer. 0.97. What is the ratio of the Expenses (% of total expenses) of Goods and services in 2005 to that in 2008?
Provide a succinct answer. 0.97. What is the ratio of the Expenses (% of total expenses) in Other expenses in 2005 to that in 2008?
Your answer should be very brief. 0.8. What is the ratio of the Expenses (% of total expenses) in Compensation of employees in 2005 to that in 2009?
Give a very brief answer. 1.3. What is the ratio of the Expenses (% of total expenses) of Goods and services in 2005 to that in 2009?
Give a very brief answer. 2.96. What is the ratio of the Expenses (% of total expenses) in Subsidies and Transfers in 2005 to that in 2009?
Your answer should be compact. 0.58. What is the ratio of the Expenses (% of total expenses) of Other expenses in 2005 to that in 2009?
Ensure brevity in your answer.  0.8. What is the ratio of the Expenses (% of total expenses) in Compensation of employees in 2006 to that in 2007?
Keep it short and to the point. 1.03. What is the ratio of the Expenses (% of total expenses) in Goods and services in 2006 to that in 2007?
Make the answer very short. 0.97. What is the ratio of the Expenses (% of total expenses) of Other expenses in 2006 to that in 2007?
Ensure brevity in your answer.  0.93. What is the ratio of the Expenses (% of total expenses) in Compensation of employees in 2006 to that in 2008?
Provide a succinct answer. 0.97. What is the ratio of the Expenses (% of total expenses) of Goods and services in 2006 to that in 2008?
Your answer should be compact. 1.02. What is the ratio of the Expenses (% of total expenses) in Subsidies and Transfers in 2006 to that in 2008?
Keep it short and to the point. 0.98. What is the ratio of the Expenses (% of total expenses) of Other expenses in 2006 to that in 2008?
Your answer should be very brief. 0.8. What is the ratio of the Expenses (% of total expenses) of Compensation of employees in 2006 to that in 2009?
Your answer should be very brief. 1.31. What is the ratio of the Expenses (% of total expenses) of Goods and services in 2006 to that in 2009?
Provide a succinct answer. 3.11. What is the ratio of the Expenses (% of total expenses) of Subsidies and Transfers in 2006 to that in 2009?
Offer a terse response. 0.56. What is the ratio of the Expenses (% of total expenses) of Other expenses in 2006 to that in 2009?
Make the answer very short. 0.8. What is the ratio of the Expenses (% of total expenses) of Compensation of employees in 2007 to that in 2008?
Provide a short and direct response. 0.94. What is the ratio of the Expenses (% of total expenses) in Goods and services in 2007 to that in 2008?
Keep it short and to the point. 1.06. What is the ratio of the Expenses (% of total expenses) in Subsidies and Transfers in 2007 to that in 2008?
Make the answer very short. 0.98. What is the ratio of the Expenses (% of total expenses) in Other expenses in 2007 to that in 2008?
Ensure brevity in your answer.  0.86. What is the ratio of the Expenses (% of total expenses) in Compensation of employees in 2007 to that in 2009?
Your answer should be compact. 1.27. What is the ratio of the Expenses (% of total expenses) of Goods and services in 2007 to that in 2009?
Provide a succinct answer. 3.22. What is the ratio of the Expenses (% of total expenses) in Subsidies and Transfers in 2007 to that in 2009?
Keep it short and to the point. 0.56. What is the ratio of the Expenses (% of total expenses) of Other expenses in 2007 to that in 2009?
Provide a short and direct response. 0.87. What is the ratio of the Expenses (% of total expenses) in Compensation of employees in 2008 to that in 2009?
Your response must be concise. 1.35. What is the ratio of the Expenses (% of total expenses) of Goods and services in 2008 to that in 2009?
Give a very brief answer. 3.05. What is the ratio of the Expenses (% of total expenses) of Subsidies and Transfers in 2008 to that in 2009?
Keep it short and to the point. 0.58. What is the ratio of the Expenses (% of total expenses) of Other expenses in 2008 to that in 2009?
Provide a succinct answer. 1. What is the difference between the highest and the second highest Expenses (% of total expenses) of Compensation of employees?
Provide a short and direct response. 0.69. What is the difference between the highest and the second highest Expenses (% of total expenses) in Goods and services?
Offer a very short reply. 0.99. What is the difference between the highest and the second highest Expenses (% of total expenses) in Subsidies and Transfers?
Provide a succinct answer. 23.73. What is the difference between the highest and the second highest Expenses (% of total expenses) of Other expenses?
Offer a very short reply. 0.03. What is the difference between the highest and the lowest Expenses (% of total expenses) in Compensation of employees?
Ensure brevity in your answer.  6.82. What is the difference between the highest and the lowest Expenses (% of total expenses) in Goods and services?
Your answer should be compact. 20.85. What is the difference between the highest and the lowest Expenses (% of total expenses) in Subsidies and Transfers?
Give a very brief answer. 26.43. What is the difference between the highest and the lowest Expenses (% of total expenses) of Other expenses?
Ensure brevity in your answer.  2.08. 